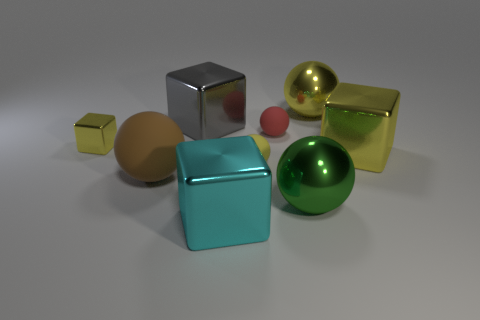Discuss the composition and balance of the image. The composition is carefully balanced with a mix of geometric shapes from spheres to cubes, arranged asymmetrically yet harmoniously. There is a considered use of space, allowing each object to stand out without overcrowding. The alignment and spacing also guide the viewer's eyes through the image, creating an aesthetically pleasing balance between form, color, and negative space. 